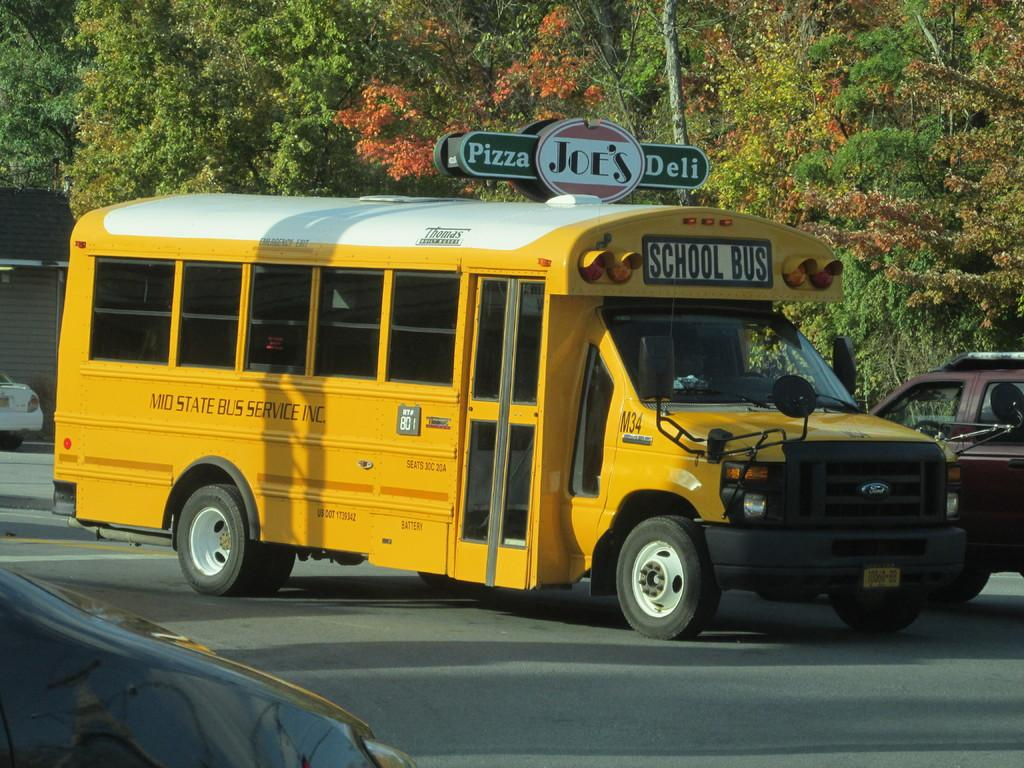<image>
Summarize the visual content of the image. School Bus featured on the road with text on the side saying: Mid State Bus Service Inc. 